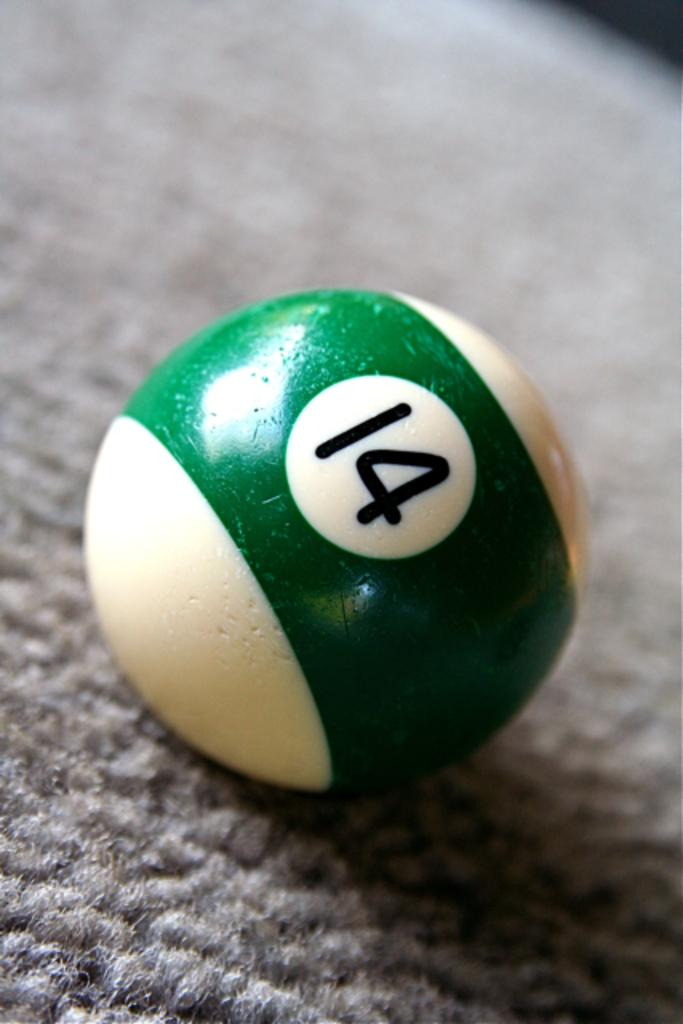Provide a one-sentence caption for the provided image. #14 ball that is used in the game of pool. 